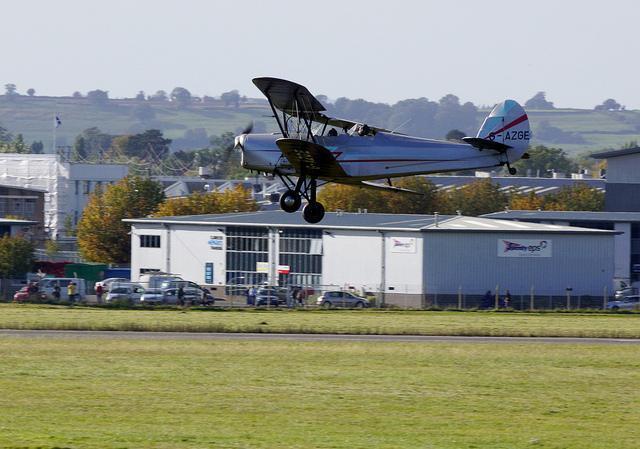How many wheels are on the ground?
Give a very brief answer. 0. How many airplanes can be seen?
Give a very brief answer. 1. 